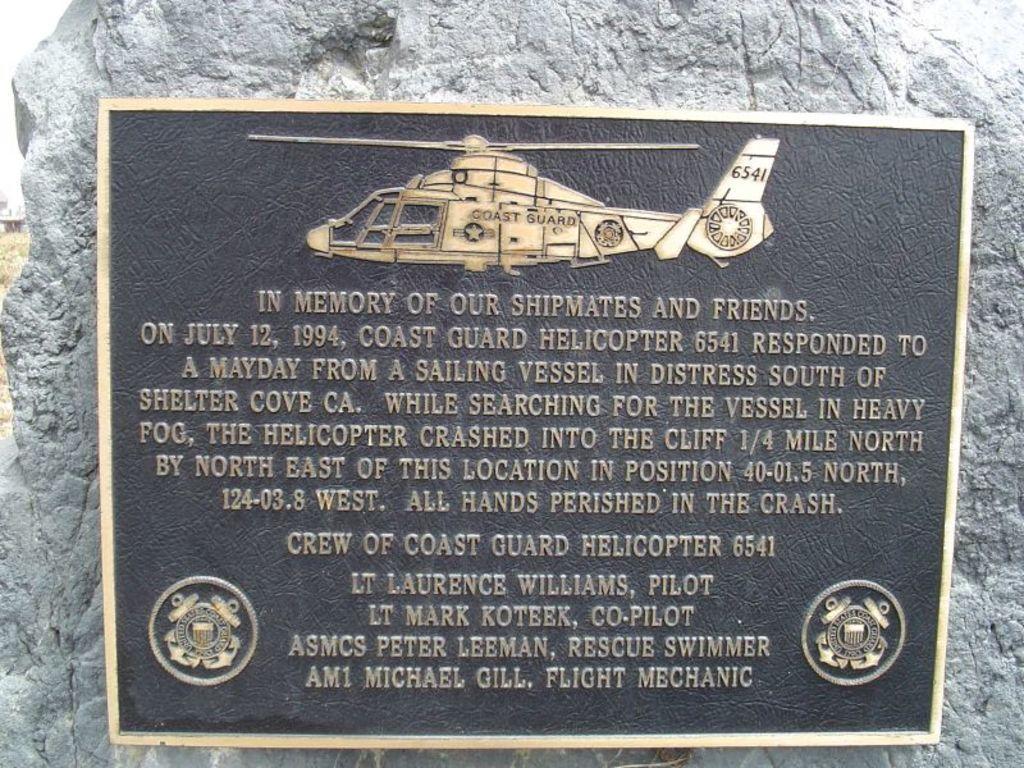Could you give a brief overview of what you see in this image? In this picture, we can see a black board on which some text is written on it. In the background, we can also see a stone. 